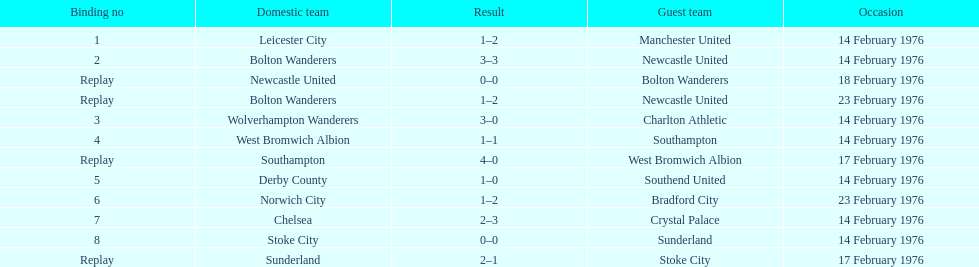What was the goal difference in the game on february 18th? 0. 